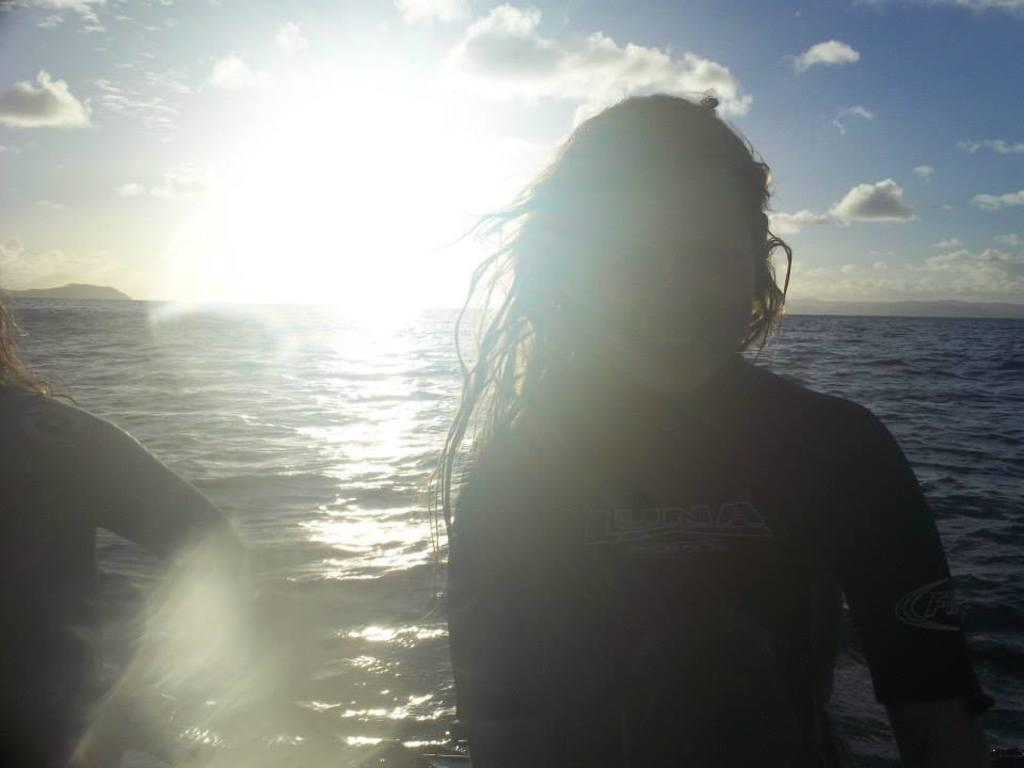Who or what can be seen in the image? There are people in the image. What is visible in the background of the image? There is water visible in the background. What is the source of light in the image? Sunlight is present in the image. What can be seen in the sky in the image? Clouds are visible in the sky. What type of grain is being sold at the market in the image? There is no market or grain present in the image; it features people and a background with water. What branch of a tree can be seen in the image? There is no tree or branch present in the image. 